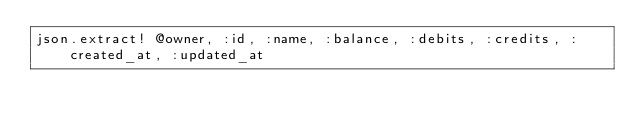<code> <loc_0><loc_0><loc_500><loc_500><_Ruby_>json.extract! @owner, :id, :name, :balance, :debits, :credits, :created_at, :updated_at
</code> 